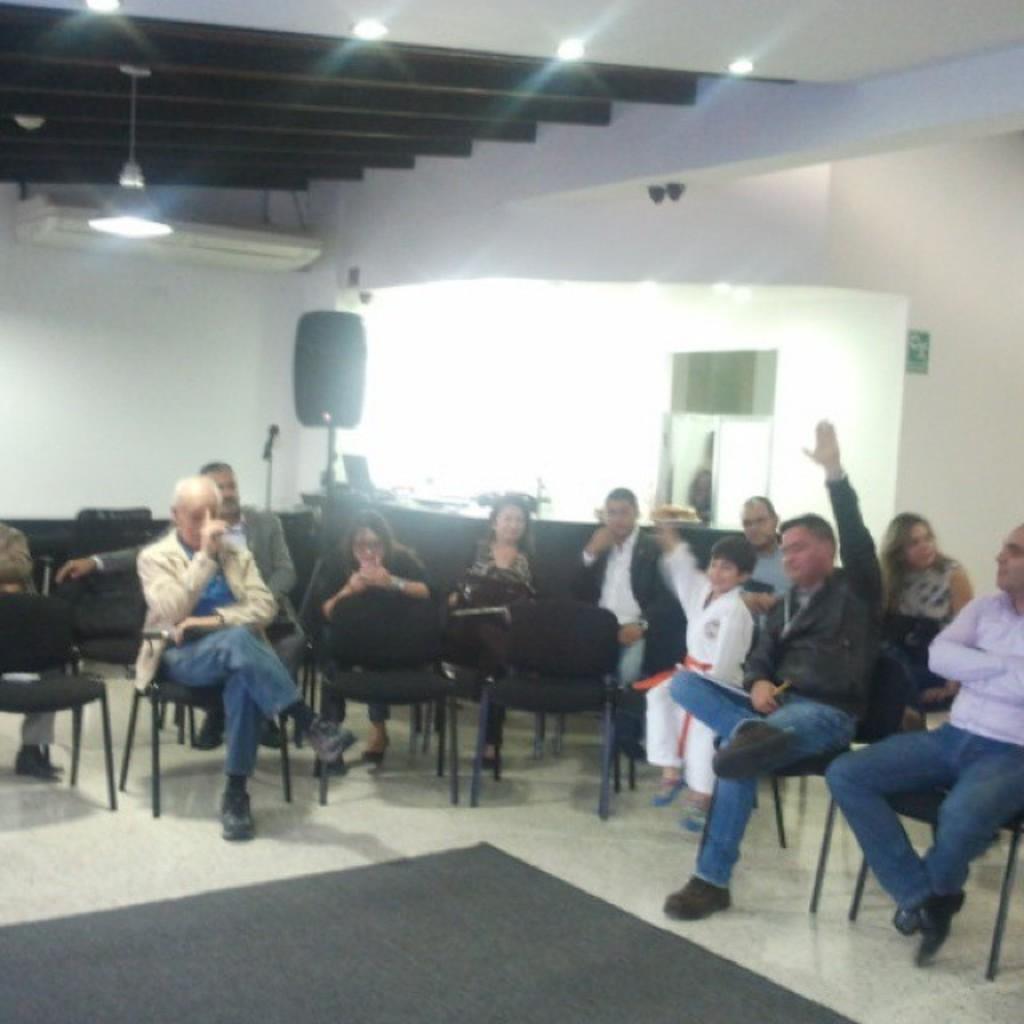Describe this image in one or two sentences. Here we can see that a group of people sitting on the chair, and at back there is the wall, and at top there are lights. 